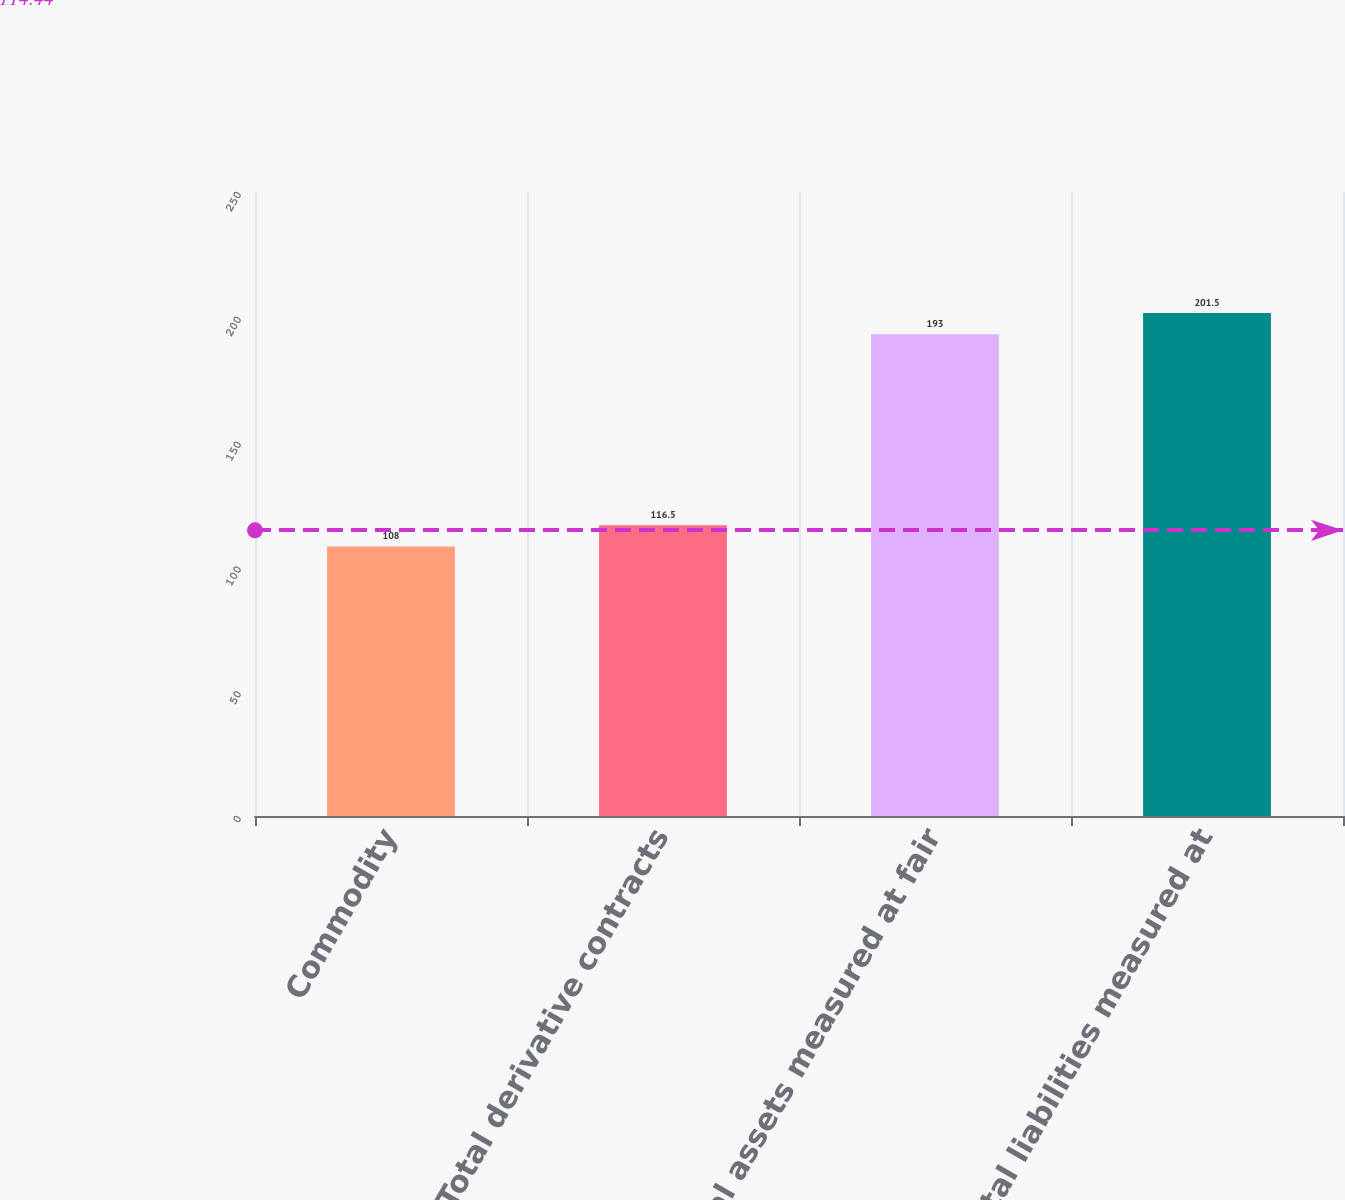<chart> <loc_0><loc_0><loc_500><loc_500><bar_chart><fcel>Commodity<fcel>Total derivative contracts<fcel>Total assets measured at fair<fcel>Total liabilities measured at<nl><fcel>108<fcel>116.5<fcel>193<fcel>201.5<nl></chart> 